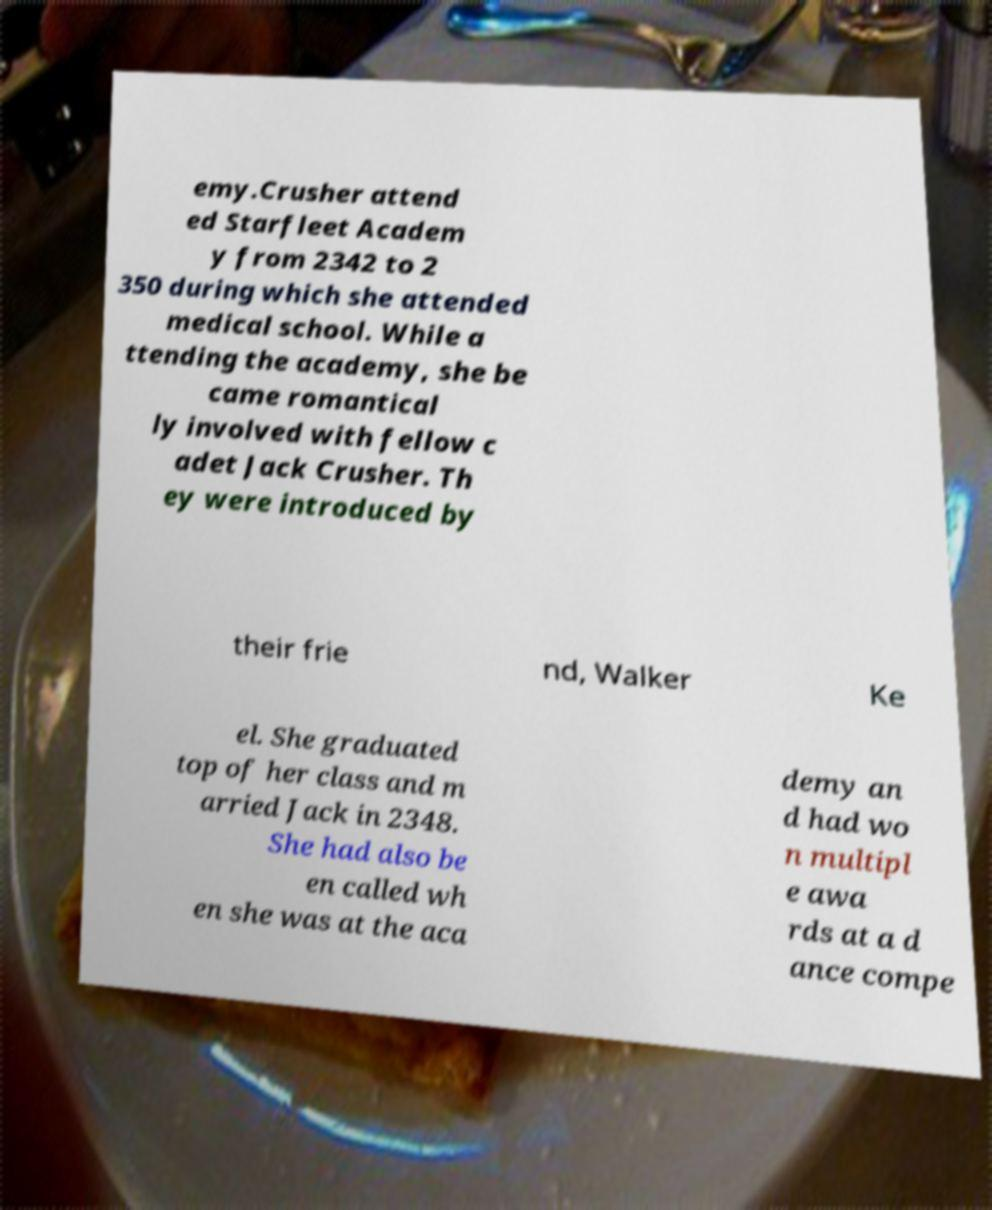There's text embedded in this image that I need extracted. Can you transcribe it verbatim? emy.Crusher attend ed Starfleet Academ y from 2342 to 2 350 during which she attended medical school. While a ttending the academy, she be came romantical ly involved with fellow c adet Jack Crusher. Th ey were introduced by their frie nd, Walker Ke el. She graduated top of her class and m arried Jack in 2348. She had also be en called wh en she was at the aca demy an d had wo n multipl e awa rds at a d ance compe 